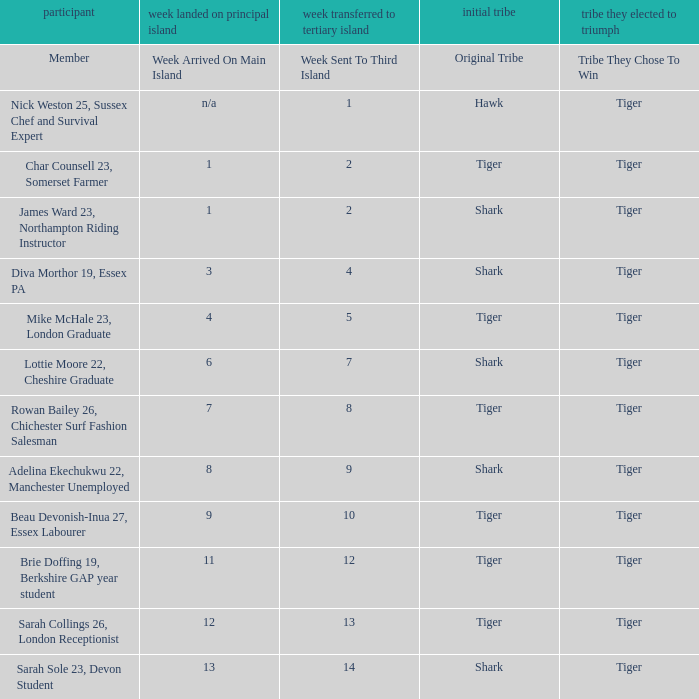What week did the member who's original tribe was shark and who was sent to the third island on week 14 arrive on the main island? 13.0. 